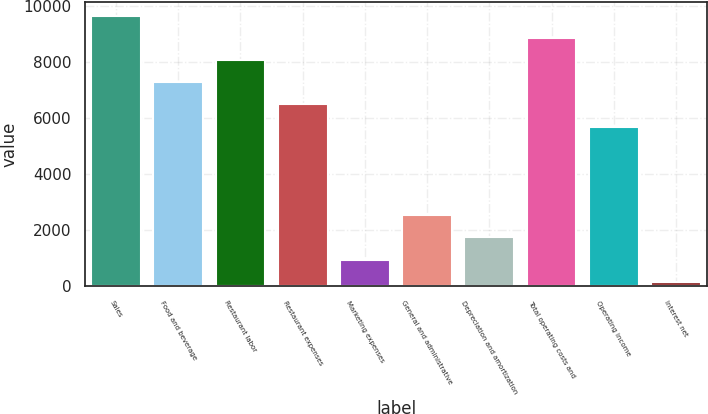Convert chart to OTSL. <chart><loc_0><loc_0><loc_500><loc_500><bar_chart><fcel>Sales<fcel>Food and beverage<fcel>Restaurant labor<fcel>Restaurant expenses<fcel>Marketing expenses<fcel>General and administrative<fcel>Depreciation and amortization<fcel>Total operating costs and<fcel>Operating income<fcel>Interest net<nl><fcel>9663.9<fcel>7288.2<fcel>8080.1<fcel>6496.3<fcel>953<fcel>2536.8<fcel>1744.9<fcel>8872<fcel>5704.4<fcel>161.1<nl></chart> 